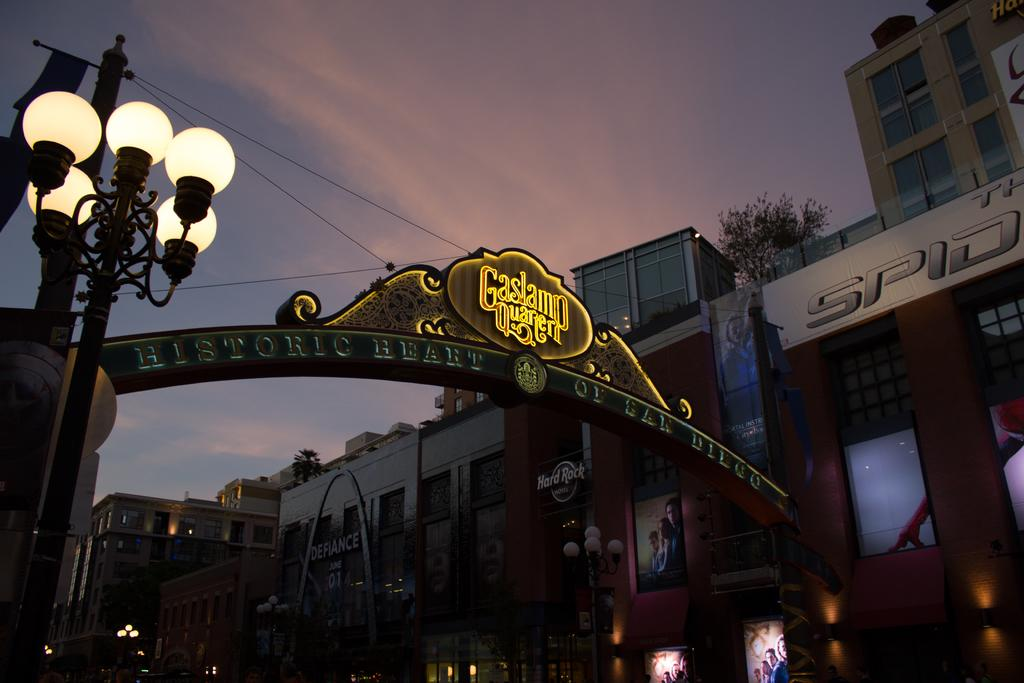Where was the image taken? The image was taken on a street. What can be seen in the background of the image? There are many buildings in the background. What is the main feature in the front of the image? There is an arch in the front of the image. What is on the left side of the image? There is a light on the left side of the image. What is visible at the top of the image? The sky is visible in the image. What can be observed in the sky? Clouds are present in the sky. How many quartz crystals can be seen in the image? There are no quartz crystals present in the image. What is the birth date of the person who took the image? The birth date of the person who took the image is not mentioned in the image or the provided facts. 